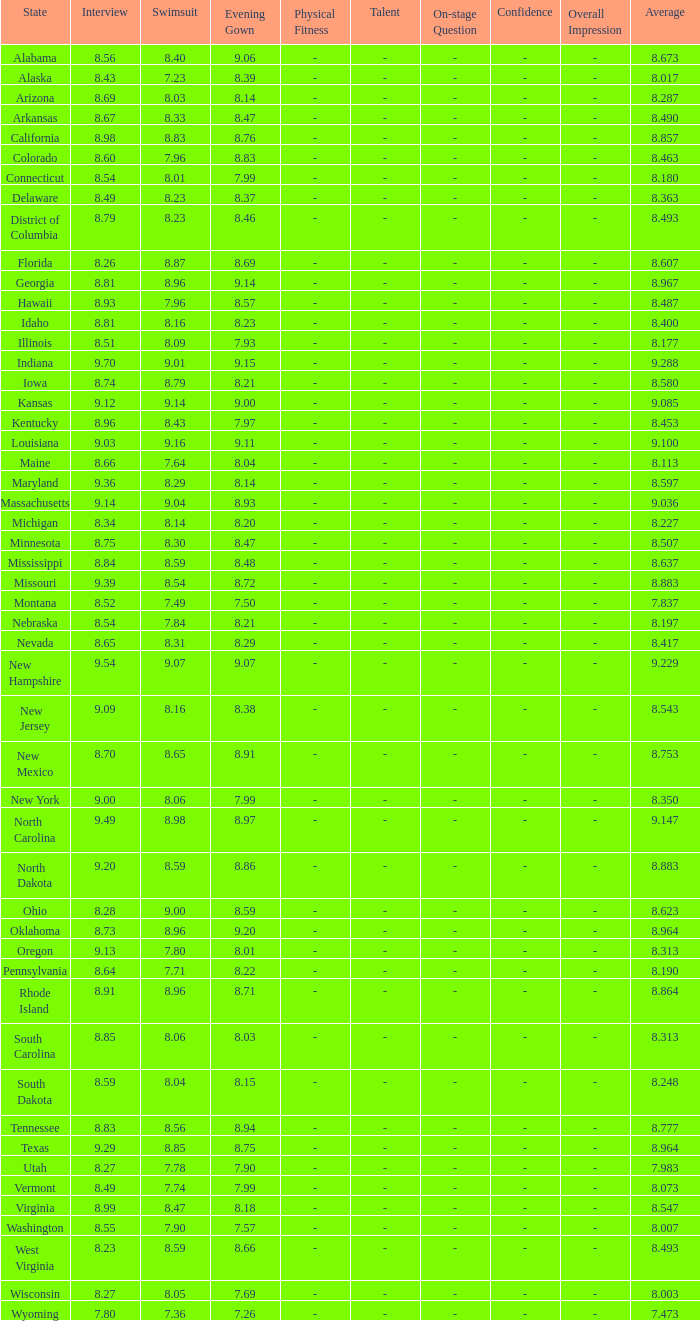Give me the full table as a dictionary. {'header': ['State', 'Interview', 'Swimsuit', 'Evening Gown', 'Physical Fitness', 'Talent', 'On-stage Question', 'Confidence', 'Overall Impression', 'Average'], 'rows': [['Alabama', '8.56', '8.40', '9.06', '-', '-', '-', '-', '-', '8.673'], ['Alaska', '8.43', '7.23', '8.39', '-', '-', '-', '-', '-', '8.017'], ['Arizona', '8.69', '8.03', '8.14', '-', '-', '-', '-', '-', '8.287'], ['Arkansas', '8.67', '8.33', '8.47', '-', '-', '-', '-', '-', '8.490'], ['California', '8.98', '8.83', '8.76', '-', '-', '-', '-', '-', '8.857'], ['Colorado', '8.60', '7.96', '8.83', '-', '-', '-', '-', '-', '8.463'], ['Connecticut', '8.54', '8.01', '7.99', '-', '-', '-', '-', '-', '8.180'], ['Delaware', '8.49', '8.23', '8.37', '-', '-', '-', '-', '-', '8.363'], ['District of Columbia', '8.79', '8.23', '8.46', '-', '-', '-', '-', '-', '8.493'], ['Florida', '8.26', '8.87', '8.69', '-', '-', '-', '-', '-', '8.607'], ['Georgia', '8.81', '8.96', '9.14', '-', '-', '-', '-', '-', '8.967'], ['Hawaii', '8.93', '7.96', '8.57', '-', '-', '-', '-', '-', '8.487'], ['Idaho', '8.81', '8.16', '8.23', '-', '-', '-', '-', '-', '8.400'], ['Illinois', '8.51', '8.09', '7.93', '-', '-', '-', '-', '-', '8.177'], ['Indiana', '9.70', '9.01', '9.15', '-', '-', '-', '-', '-', '9.288'], ['Iowa', '8.74', '8.79', '8.21', '-', '-', '-', '-', '-', '8.580'], ['Kansas', '9.12', '9.14', '9.00', '-', '-', '-', '-', '-', '9.085'], ['Kentucky', '8.96', '8.43', '7.97', '-', '-', '-', '-', '-', '8.453'], ['Louisiana', '9.03', '9.16', '9.11', '-', '-', '-', '-', '-', '9.100'], ['Maine', '8.66', '7.64', '8.04', '-', '-', '-', '-', '-', '8.113'], ['Maryland', '9.36', '8.29', '8.14', '-', '-', '-', '-', '-', '8.597'], ['Massachusetts', '9.14', '9.04', '8.93', '-', '-', '-', '-', '-', '9.036'], ['Michigan', '8.34', '8.14', '8.20', '-', '-', '-', '-', '-', '8.227'], ['Minnesota', '8.75', '8.30', '8.47', '-', '-', '-', '-', '-', '8.507'], ['Mississippi', '8.84', '8.59', '8.48', '-', '-', '-', '-', '-', '8.637'], ['Missouri', '9.39', '8.54', '8.72', '-', '-', '-', '-', '-', '8.883'], ['Montana', '8.52', '7.49', '7.50', '-', '-', '-', '-', '-', '7.837'], ['Nebraska', '8.54', '7.84', '8.21', '-', '-', '-', '-', '-', '8.197'], ['Nevada', '8.65', '8.31', '8.29', '-', '-', '-', '-', '-', '8.417'], ['New Hampshire', '9.54', '9.07', '9.07', '-', '-', '-', '-', '-', '9.229'], ['New Jersey', '9.09', '8.16', '8.38', '-', '-', '-', '-', '-', '8.543'], ['New Mexico', '8.70', '8.65', '8.91', '-', '-', '-', '-', '-', '8.753'], ['New York', '9.00', '8.06', '7.99', '-', '-', '-', '-', '-', '8.350'], ['North Carolina', '9.49', '8.98', '8.97', '-', '-', '-', '-', '-', '9.147'], ['North Dakota', '9.20', '8.59', '8.86', '-', '-', '-', '-', '-', '8.883'], ['Ohio', '8.28', '9.00', '8.59', '-', '-', '-', '-', '-', '8.623'], ['Oklahoma', '8.73', '8.96', '9.20', '-', '-', '-', '-', '-', '8.964'], ['Oregon', '9.13', '7.80', '8.01', '-', '-', '-', '-', '-', '8.313'], ['Pennsylvania', '8.64', '7.71', '8.22', '-', '-', '-', '-', '-', '8.190'], ['Rhode Island', '8.91', '8.96', '8.71', '-', '-', '-', '-', '-', '8.864'], ['South Carolina', '8.85', '8.06', '8.03', '-', '-', '-', '-', '-', '8.313'], ['South Dakota', '8.59', '8.04', '8.15', '-', '-', '-', '-', '-', '8.248'], ['Tennessee', '8.83', '8.56', '8.94', '-', '-', '-', '-', '-', '8.777'], ['Texas', '9.29', '8.85', '8.75', '-', '-', '-', '-', '-', '8.964'], ['Utah', '8.27', '7.78', '7.90', '-', '-', '-', '-', '-', '7.983'], ['Vermont', '8.49', '7.74', '7.99', '-', '-', '-', '-', '-', '8.073'], ['Virginia', '8.99', '8.47', '8.18', '-', '-', '-', '-', '-', '8.547'], ['Washington', '8.55', '7.90', '7.57', '-', '-', '-', '-', '-', '8.007'], ['West Virginia', '8.23', '8.59', '8.66', '-', '-', '-', '-', '-', '8.493'], ['Wisconsin', '8.27', '8.05', '7.69', '-', '-', '-', '-', '-', '8.003'], ['Wyoming', '7.80', '7.36', '7.26', '-', '-', '-', '-', '-', '7.473']]} Tell me the sum of interview for evening gown more than 8.37 and average of 8.363 None. 